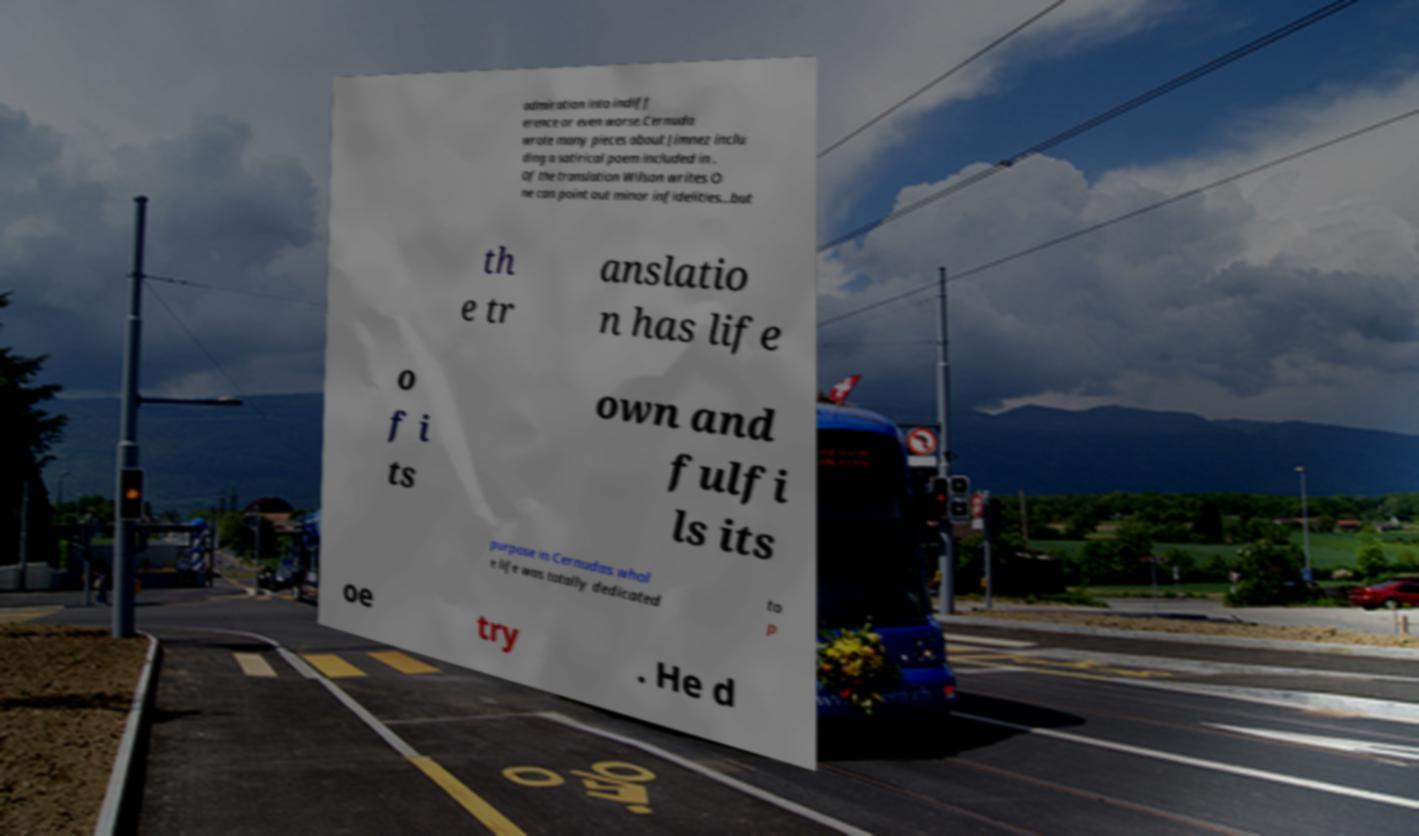Please identify and transcribe the text found in this image. admiration into indiff erence or even worse.Cernuda wrote many pieces about Jimnez inclu ding a satirical poem included in . Of the translation Wilson writes O ne can point out minor infidelities...but th e tr anslatio n has life o f i ts own and fulfi ls its purpose in Cernudas whol e life was totally dedicated to p oe try . He d 